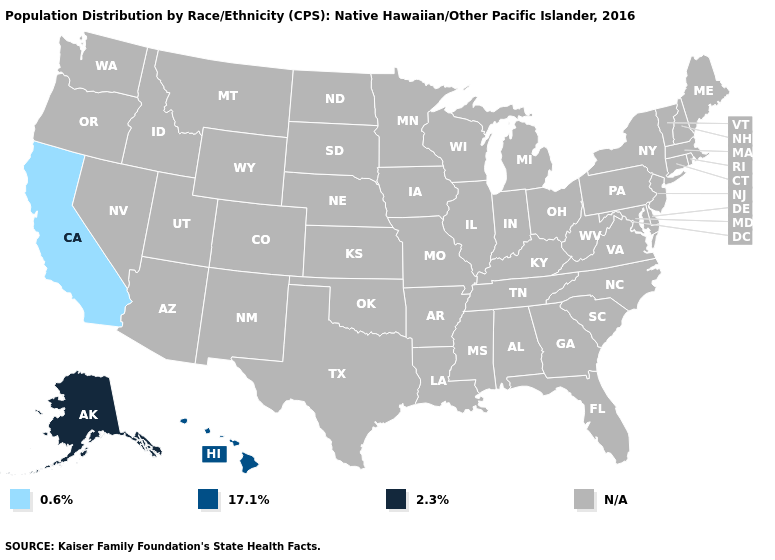What is the value of Arkansas?
Quick response, please. N/A. Which states have the lowest value in the USA?
Quick response, please. California. What is the value of New Jersey?
Answer briefly. N/A. Which states have the highest value in the USA?
Answer briefly. Alaska. Does Hawaii have the highest value in the West?
Answer briefly. No. What is the value of South Carolina?
Short answer required. N/A. What is the value of Connecticut?
Quick response, please. N/A. What is the value of Florida?
Write a very short answer. N/A. Which states have the lowest value in the West?
Give a very brief answer. California. 